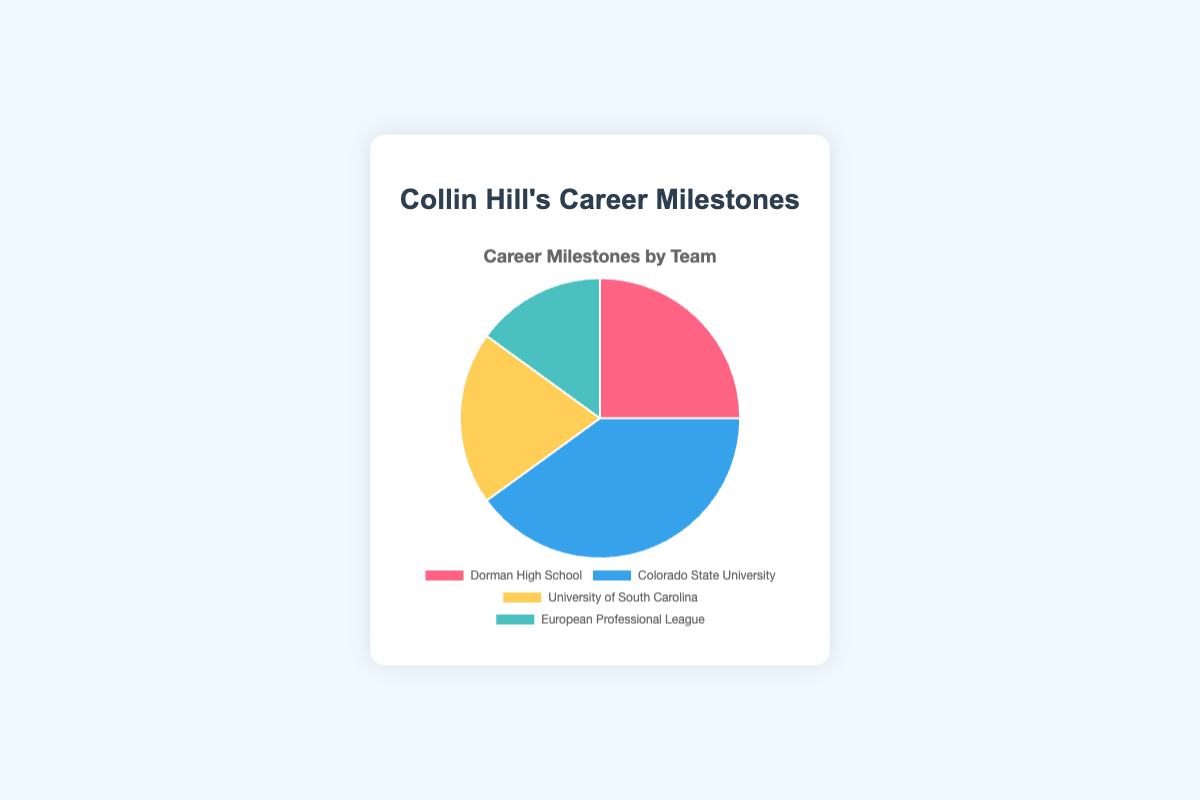What percentage of Collin Hill's career milestones occurred at Colorado State University? First, identify the number of milestones at Colorado State University, which is 40. Then, find the total number of milestones by summing the numbers from all teams (25 + 40 + 20 + 15 = 100). The percentage is given by (40 / 100) * 100%.
Answer: 40% Which team has the fewest career milestones for Collin Hill? Check the milestone numbers for all teams: Dorman High School (25), Colorado State University (40), University of South Carolina (20), and European Professional League (15). The European Professional League has the fewest at 15.
Answer: European Professional League How many more milestones did Collin Hill achieve at Colorado State University compared to the University of South Carolina? The milestones at Colorado State University are 40, and at the University of South Carolina, they are 20. Subtract 20 from 40 to find the difference.
Answer: 20 What is the sum of milestones achieved during Collin Hill's college years? Sum the milestones from Colorado State University and the University of South Carolina (40 + 20).
Answer: 60 What fraction of Collin Hill's milestones happened after high school, including both college and professional milestones? Sum the milestones after high school: Colorado State University (40), University of South Carolina (20), and European Professional League (15). The total is 75 out of the overall 100 milestones. The fraction is 75/100. Simplified, this is 3/4.
Answer: 3/4 Which team represents the largest portion of the pie chart in terms of milestones? Look for the team with the largest milestone number: Dorman High School (25), Colorado State University (40), University of South Carolina (20), European Professional League (15). Colorado State University has the largest portion with 40 milestones.
Answer: Colorado State University What color represents the milestones achieved at Dorman High School in the pie chart? Refer to the pie chart colors: Dorman High School is represented by the first color listed, which is red.
Answer: Red By how much do the milestones at Dorman High School and the European Professional League combined exceed those at the University of South Carolina? Add milestones from Dorman High School (25) and European Professional League (15), which is 40. Then subtract the milestones at the University of South Carolina (20) from this sum: 40 - 20 = 20.
Answer: 20 What is the average number of milestones for the teams that Collin Hill has been part of? Sum the total milestones (25 + 40 + 20 + 15 = 100) and divide by the number of teams (4): 100 / 4.
Answer: 25 If you reorder the teams by milestone count from highest to lowest, which team comes third? List the milestones by count: Colorado State University (40), Dorman High School (25), University of South Carolina (20), European Professional League (15). The third in order is the University of South Carolina with 20 milestones.
Answer: University of South Carolina 